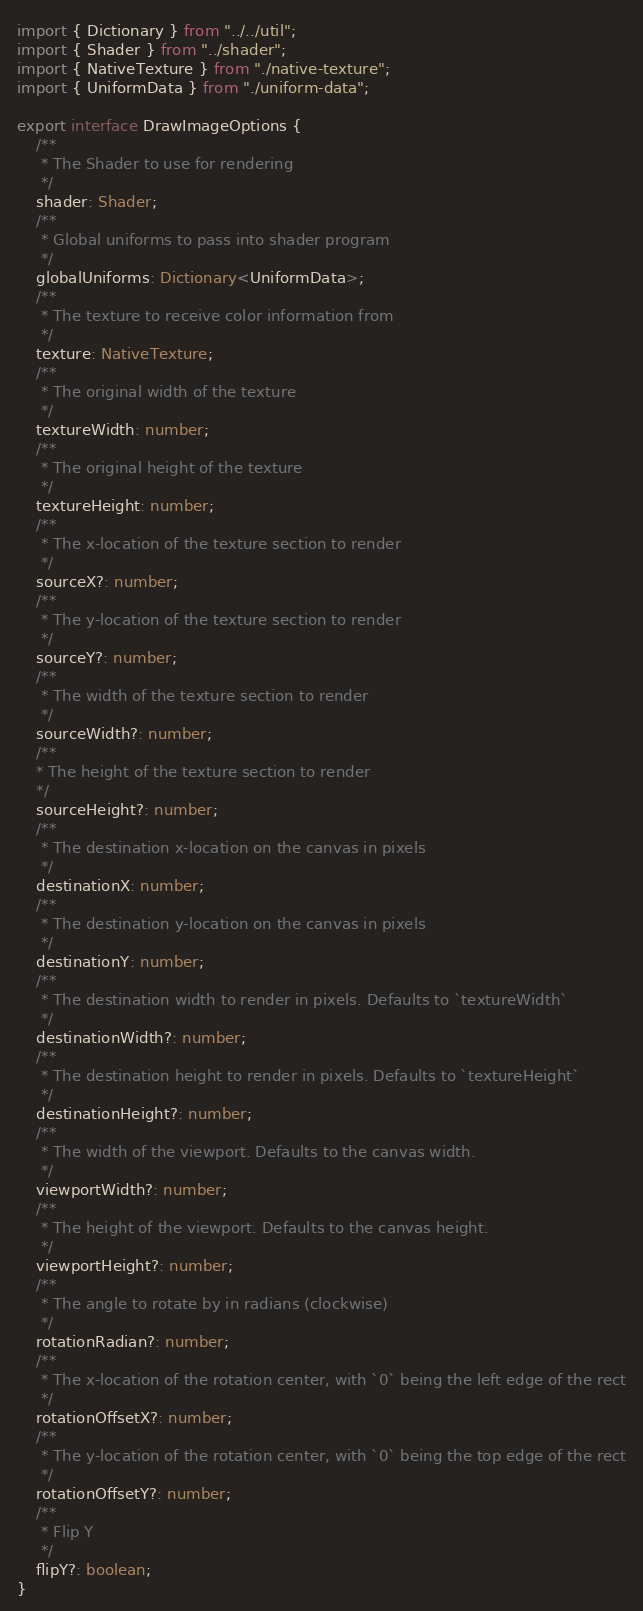<code> <loc_0><loc_0><loc_500><loc_500><_TypeScript_>import { Dictionary } from "../../util";
import { Shader } from "../shader";
import { NativeTexture } from "./native-texture";
import { UniformData } from "./uniform-data";

export interface DrawImageOptions {
    /**
     * The Shader to use for rendering
     */
    shader: Shader;
    /**
     * Global uniforms to pass into shader program
     */
    globalUniforms: Dictionary<UniformData>;
    /**
     * The texture to receive color information from
     */
    texture: NativeTexture;
    /**
     * The original width of the texture
     */
    textureWidth: number;
    /**
     * The original height of the texture
     */
    textureHeight: number;
    /**
     * The x-location of the texture section to render
     */
    sourceX?: number;
    /**
     * The y-location of the texture section to render
     */
    sourceY?: number;
    /**
     * The width of the texture section to render
     */
    sourceWidth?: number;
    /**
    * The height of the texture section to render
    */
    sourceHeight?: number;
    /**
     * The destination x-location on the canvas in pixels
     */
    destinationX: number;
    /**
     * The destination y-location on the canvas in pixels
     */
    destinationY: number;
    /**
     * The destination width to render in pixels. Defaults to `textureWidth`
     */
    destinationWidth?: number;
    /**
     * The destination height to render in pixels. Defaults to `textureHeight`
     */
    destinationHeight?: number;
    /**
     * The width of the viewport. Defaults to the canvas width.
     */
    viewportWidth?: number;
    /**
     * The height of the viewport. Defaults to the canvas height.
     */
    viewportHeight?: number;
    /**
     * The angle to rotate by in radians (clockwise)
     */
    rotationRadian?: number;
    /**
     * The x-location of the rotation center, with `0` being the left edge of the rect
     */
    rotationOffsetX?: number;
    /**
     * The y-location of the rotation center, with `0` being the top edge of the rect
     */
    rotationOffsetY?: number;
    /**
     * Flip Y
     */
    flipY?: boolean;
}</code> 